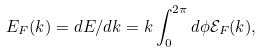Convert formula to latex. <formula><loc_0><loc_0><loc_500><loc_500>E _ { F } ( k ) = d E / d k = k \int _ { 0 } ^ { 2 \pi } d \phi \mathcal { E } _ { F } ( k ) ,</formula> 